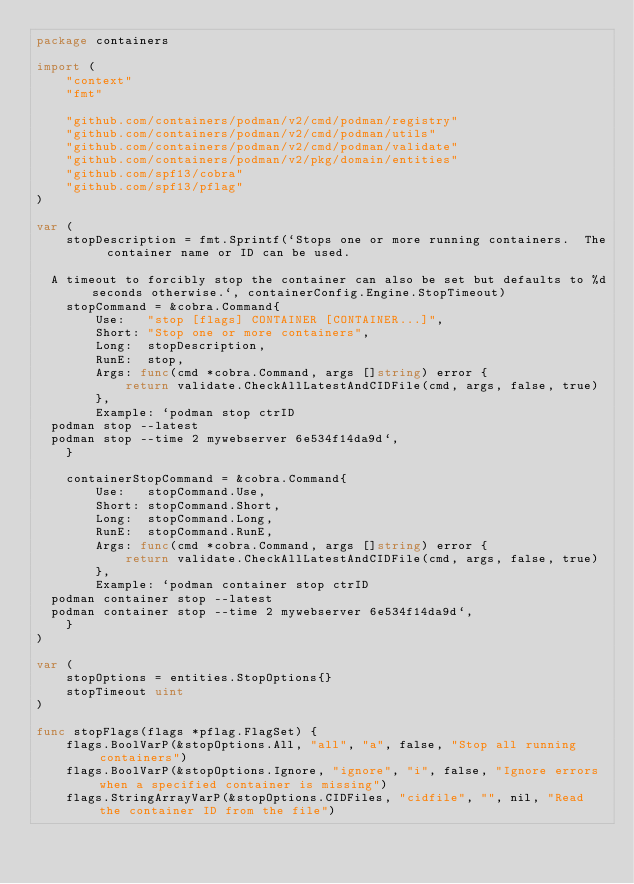<code> <loc_0><loc_0><loc_500><loc_500><_Go_>package containers

import (
	"context"
	"fmt"

	"github.com/containers/podman/v2/cmd/podman/registry"
	"github.com/containers/podman/v2/cmd/podman/utils"
	"github.com/containers/podman/v2/cmd/podman/validate"
	"github.com/containers/podman/v2/pkg/domain/entities"
	"github.com/spf13/cobra"
	"github.com/spf13/pflag"
)

var (
	stopDescription = fmt.Sprintf(`Stops one or more running containers.  The container name or ID can be used.

  A timeout to forcibly stop the container can also be set but defaults to %d seconds otherwise.`, containerConfig.Engine.StopTimeout)
	stopCommand = &cobra.Command{
		Use:   "stop [flags] CONTAINER [CONTAINER...]",
		Short: "Stop one or more containers",
		Long:  stopDescription,
		RunE:  stop,
		Args: func(cmd *cobra.Command, args []string) error {
			return validate.CheckAllLatestAndCIDFile(cmd, args, false, true)
		},
		Example: `podman stop ctrID
  podman stop --latest
  podman stop --time 2 mywebserver 6e534f14da9d`,
	}

	containerStopCommand = &cobra.Command{
		Use:   stopCommand.Use,
		Short: stopCommand.Short,
		Long:  stopCommand.Long,
		RunE:  stopCommand.RunE,
		Args: func(cmd *cobra.Command, args []string) error {
			return validate.CheckAllLatestAndCIDFile(cmd, args, false, true)
		},
		Example: `podman container stop ctrID
  podman container stop --latest
  podman container stop --time 2 mywebserver 6e534f14da9d`,
	}
)

var (
	stopOptions = entities.StopOptions{}
	stopTimeout uint
)

func stopFlags(flags *pflag.FlagSet) {
	flags.BoolVarP(&stopOptions.All, "all", "a", false, "Stop all running containers")
	flags.BoolVarP(&stopOptions.Ignore, "ignore", "i", false, "Ignore errors when a specified container is missing")
	flags.StringArrayVarP(&stopOptions.CIDFiles, "cidfile", "", nil, "Read the container ID from the file")</code> 